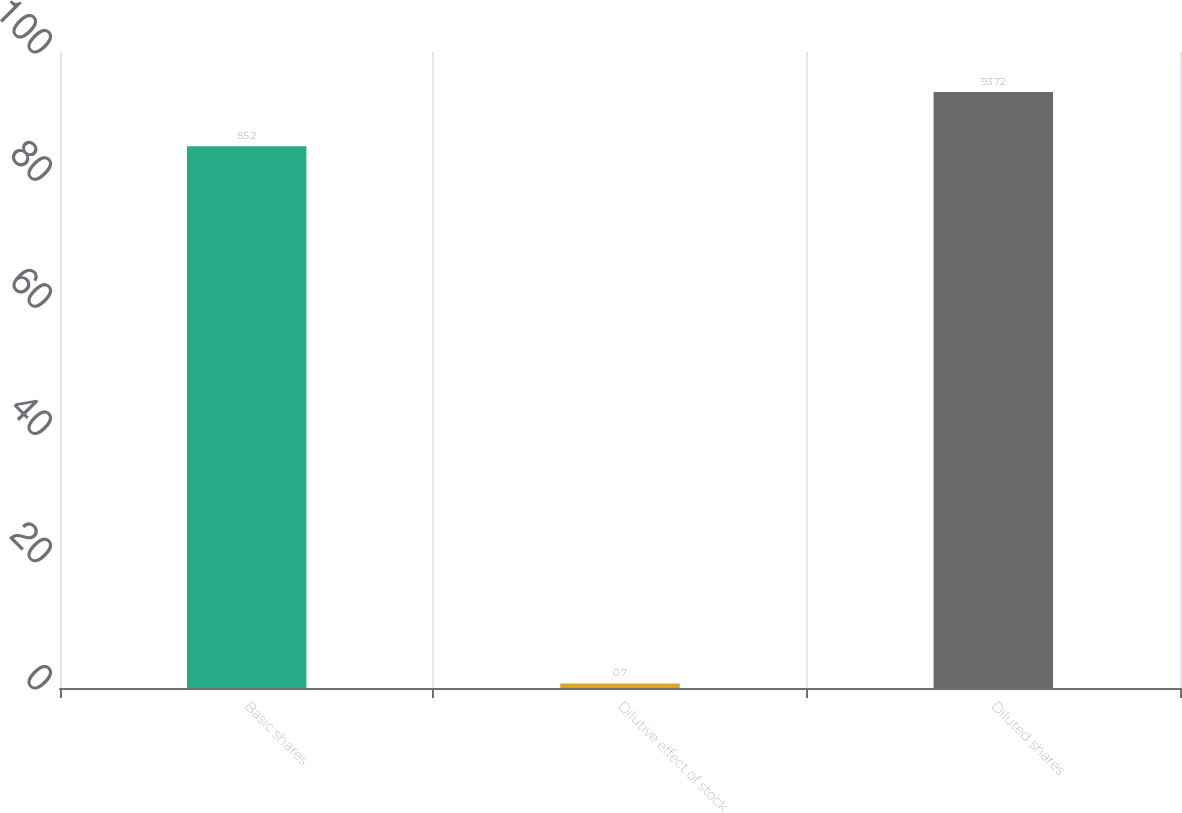<chart> <loc_0><loc_0><loc_500><loc_500><bar_chart><fcel>Basic shares<fcel>Dilutive effect of stock<fcel>Diluted shares<nl><fcel>85.2<fcel>0.7<fcel>93.72<nl></chart> 